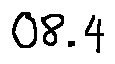<formula> <loc_0><loc_0><loc_500><loc_500>0 8 . 4</formula> 